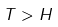Convert formula to latex. <formula><loc_0><loc_0><loc_500><loc_500>T > H</formula> 